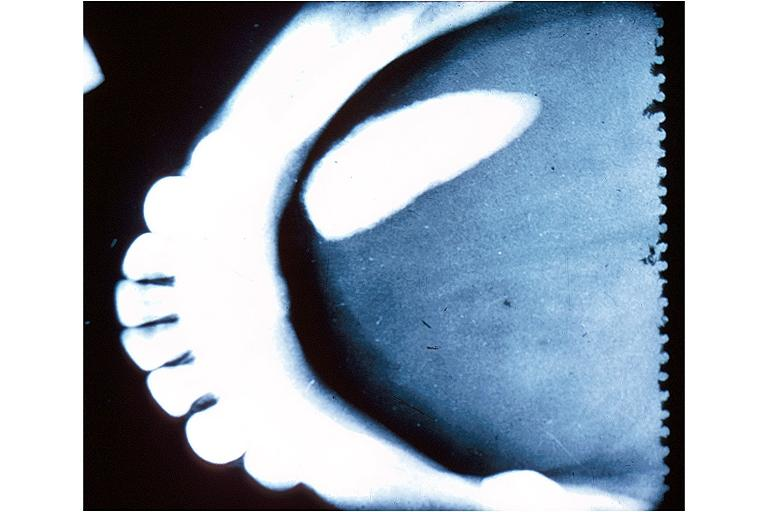does glioma show sialolith?
Answer the question using a single word or phrase. No 